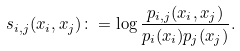Convert formula to latex. <formula><loc_0><loc_0><loc_500><loc_500>s _ { i , j } ( x _ { i } , x _ { j } ) \colon = \log \frac { p _ { i , j } ( x _ { i } , x _ { j } ) } { p _ { i } ( x _ { i } ) p _ { j } ( x _ { j } ) } .</formula> 